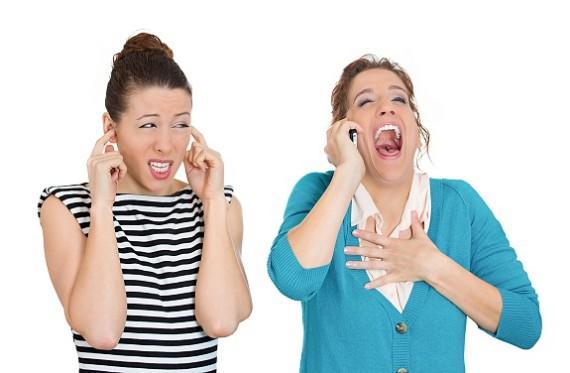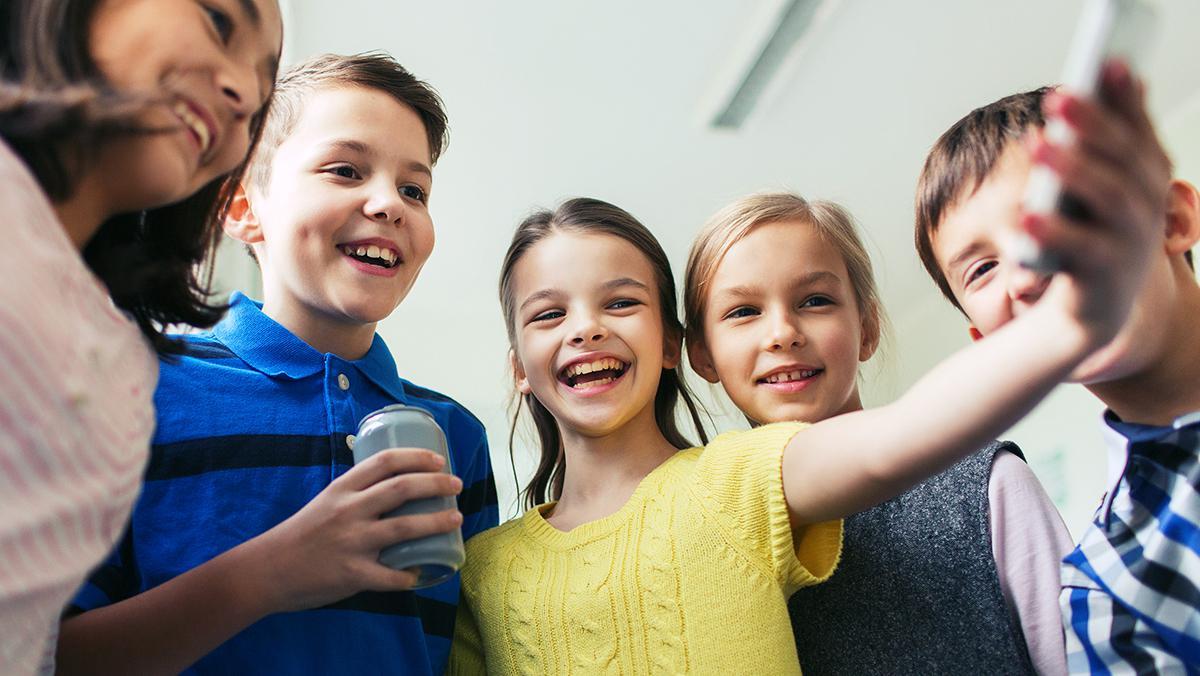The first image is the image on the left, the second image is the image on the right. For the images shown, is this caption "The left image contains a row of exactly three girls, and each girl is looking at a phone, but not every girl is holding a phone." true? Answer yes or no. No. The first image is the image on the left, the second image is the image on the right. Analyze the images presented: Is the assertion "The left and right image contains the same number of people on their phones." valid? Answer yes or no. No. 